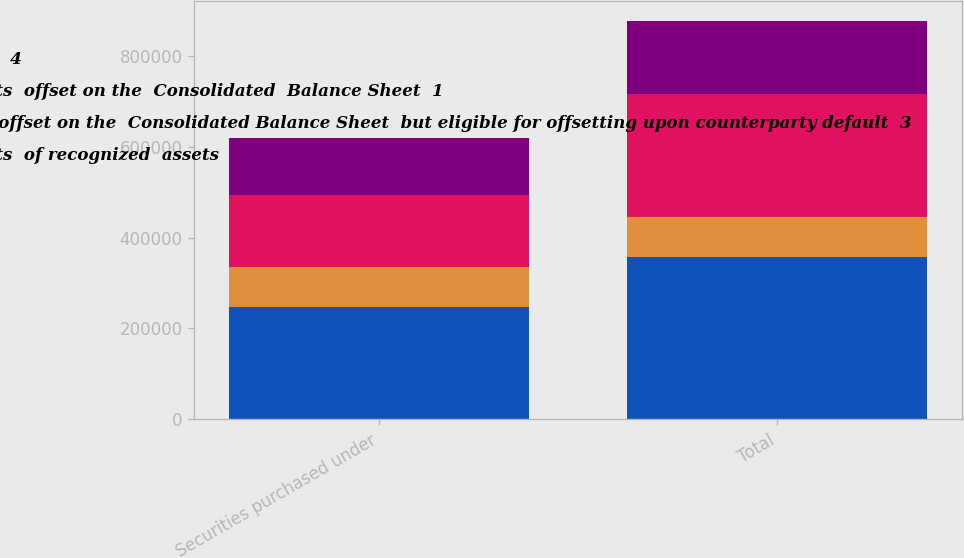<chart> <loc_0><loc_0><loc_500><loc_500><stacked_bar_chart><ecel><fcel>Securities purchased under<fcel>Total<nl><fcel>Net  amounts  4<fcel>246788<fcel>358108<nl><fcel>Gross amounts  offset on the  Consolidated  Balance Sheet  1<fcel>87424<fcel>87424<nl><fcel>Amounts not offset on the  Consolidated Balance Sheet  but eligible for offsetting upon counterparty default  3<fcel>159364<fcel>270684<nl><fcel>Gross amounts  of recognized  assets<fcel>124557<fcel>160323<nl></chart> 